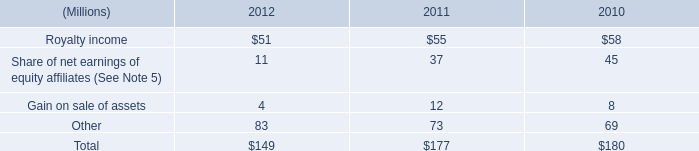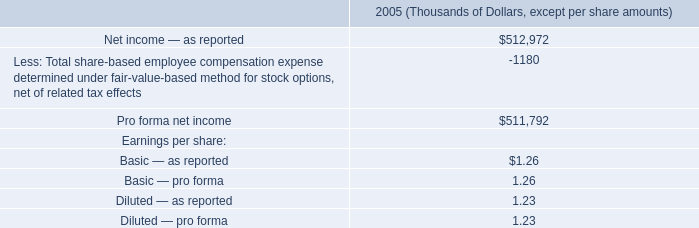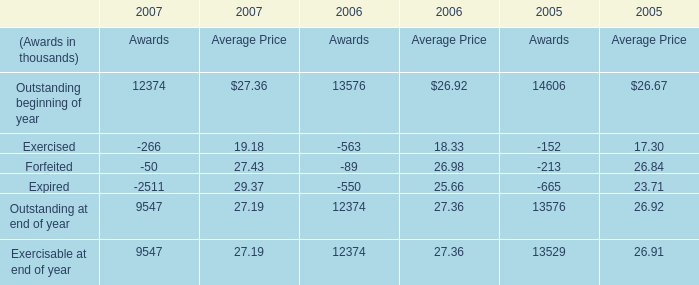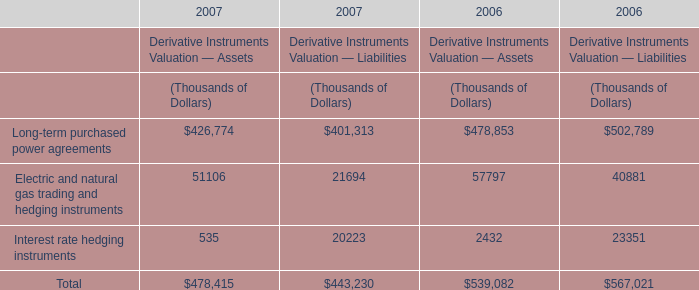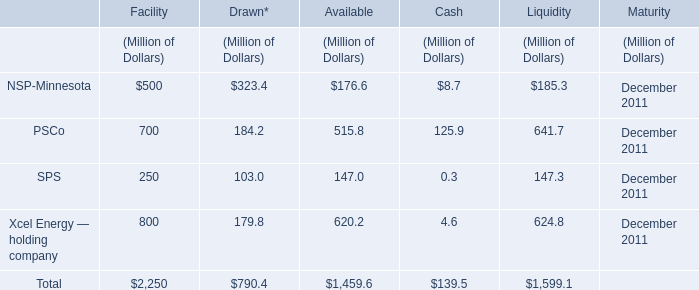what was the change in millions of total stock-based compensation cost from 2010 to 2011? 
Computations: (36 - 52)
Answer: -16.0. 